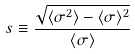Convert formula to latex. <formula><loc_0><loc_0><loc_500><loc_500>s \equiv \frac { \sqrt { \langle \sigma ^ { 2 } \rangle - \langle \sigma \rangle ^ { 2 } } } { \langle \sigma \rangle }</formula> 